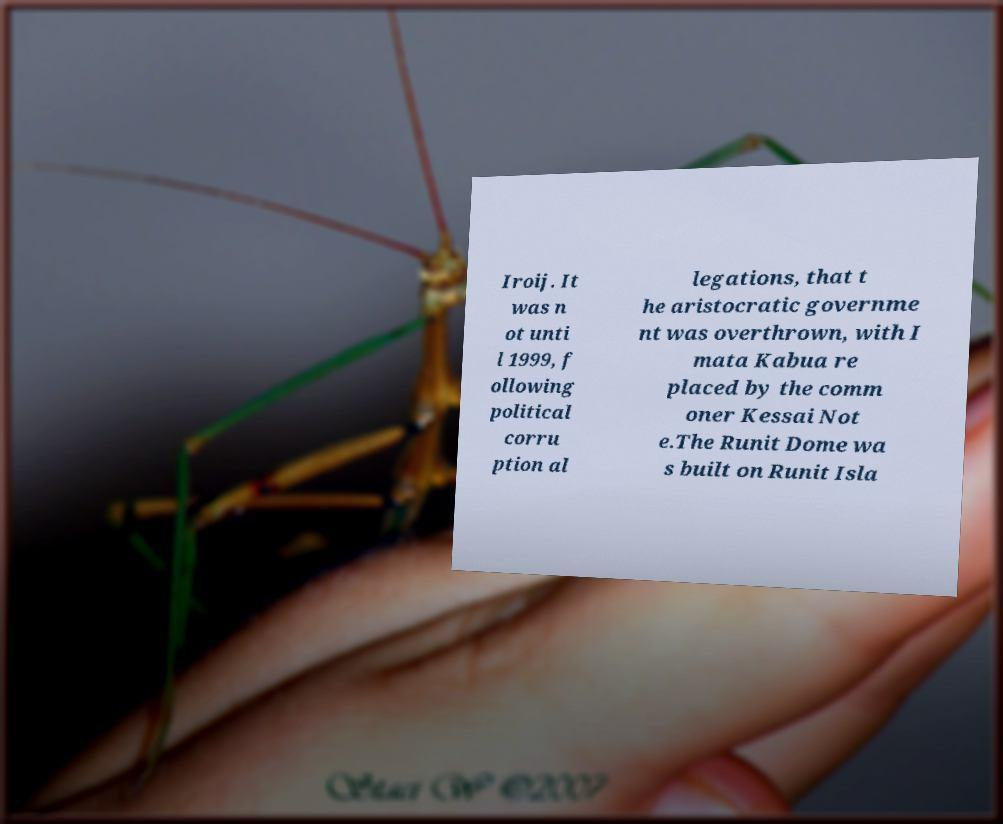There's text embedded in this image that I need extracted. Can you transcribe it verbatim? Iroij. It was n ot unti l 1999, f ollowing political corru ption al legations, that t he aristocratic governme nt was overthrown, with I mata Kabua re placed by the comm oner Kessai Not e.The Runit Dome wa s built on Runit Isla 